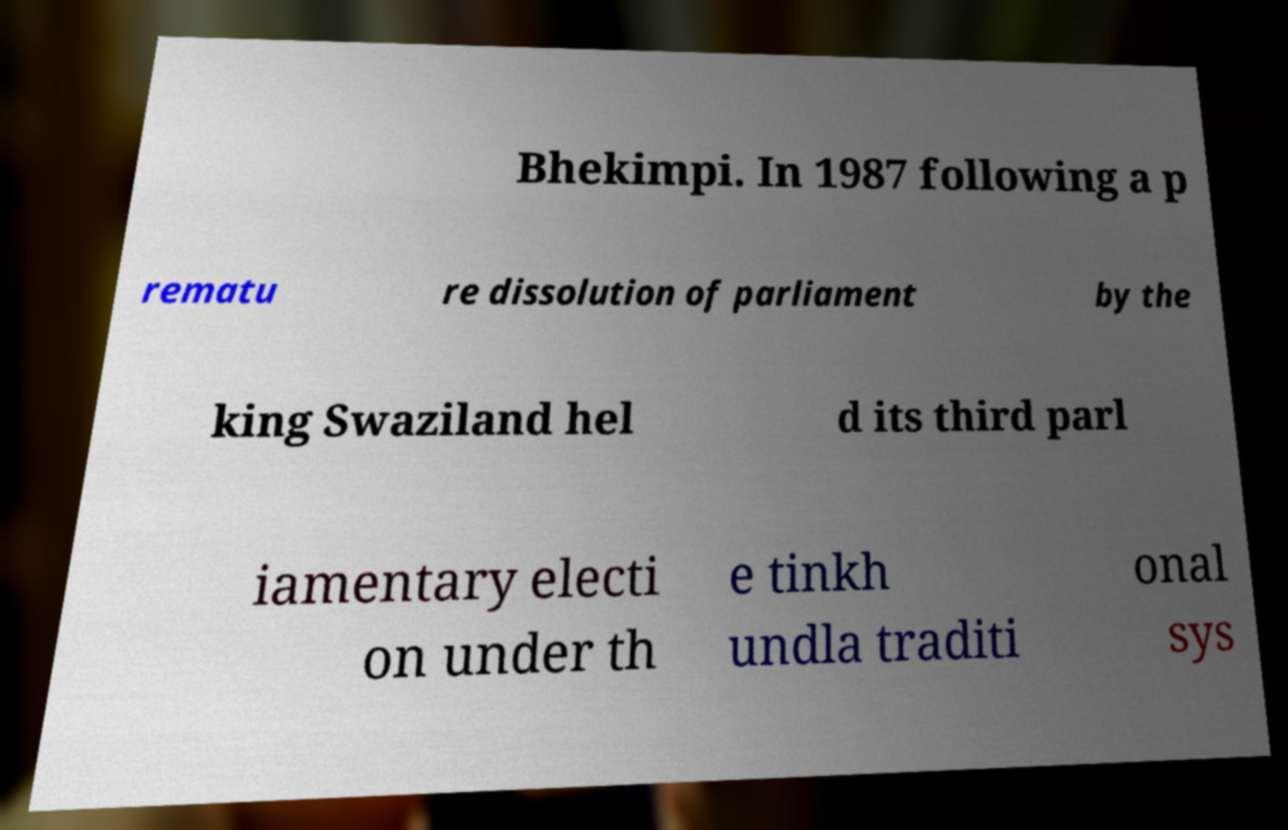Please read and relay the text visible in this image. What does it say? Bhekimpi. In 1987 following a p rematu re dissolution of parliament by the king Swaziland hel d its third parl iamentary electi on under th e tinkh undla traditi onal sys 